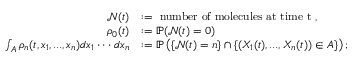<formula> <loc_0><loc_0><loc_500><loc_500>\begin{array} { r l } { \mathcal { N } ( t ) } & { \colon = n u m b e r o f m o l e c u l e s a t t i m e t , } \\ { \rho _ { 0 } ( t ) } & { \colon = \mathbb { P } ( \mathcal { N } ( t ) = 0 ) } \\ { \int _ { A } \rho _ { n } ( t , x _ { 1 } , \dots , x _ { n } ) d x _ { 1 } \cdot \cdot \cdot d x _ { n } } & { \colon = \mathbb { P } \left ( \{ \mathcal { N } ( t ) = n \} \cap \{ ( X _ { 1 } ( t ) , \dots , X _ { n } ( t ) ) \in A \} \right ) ; } \end{array}</formula> 